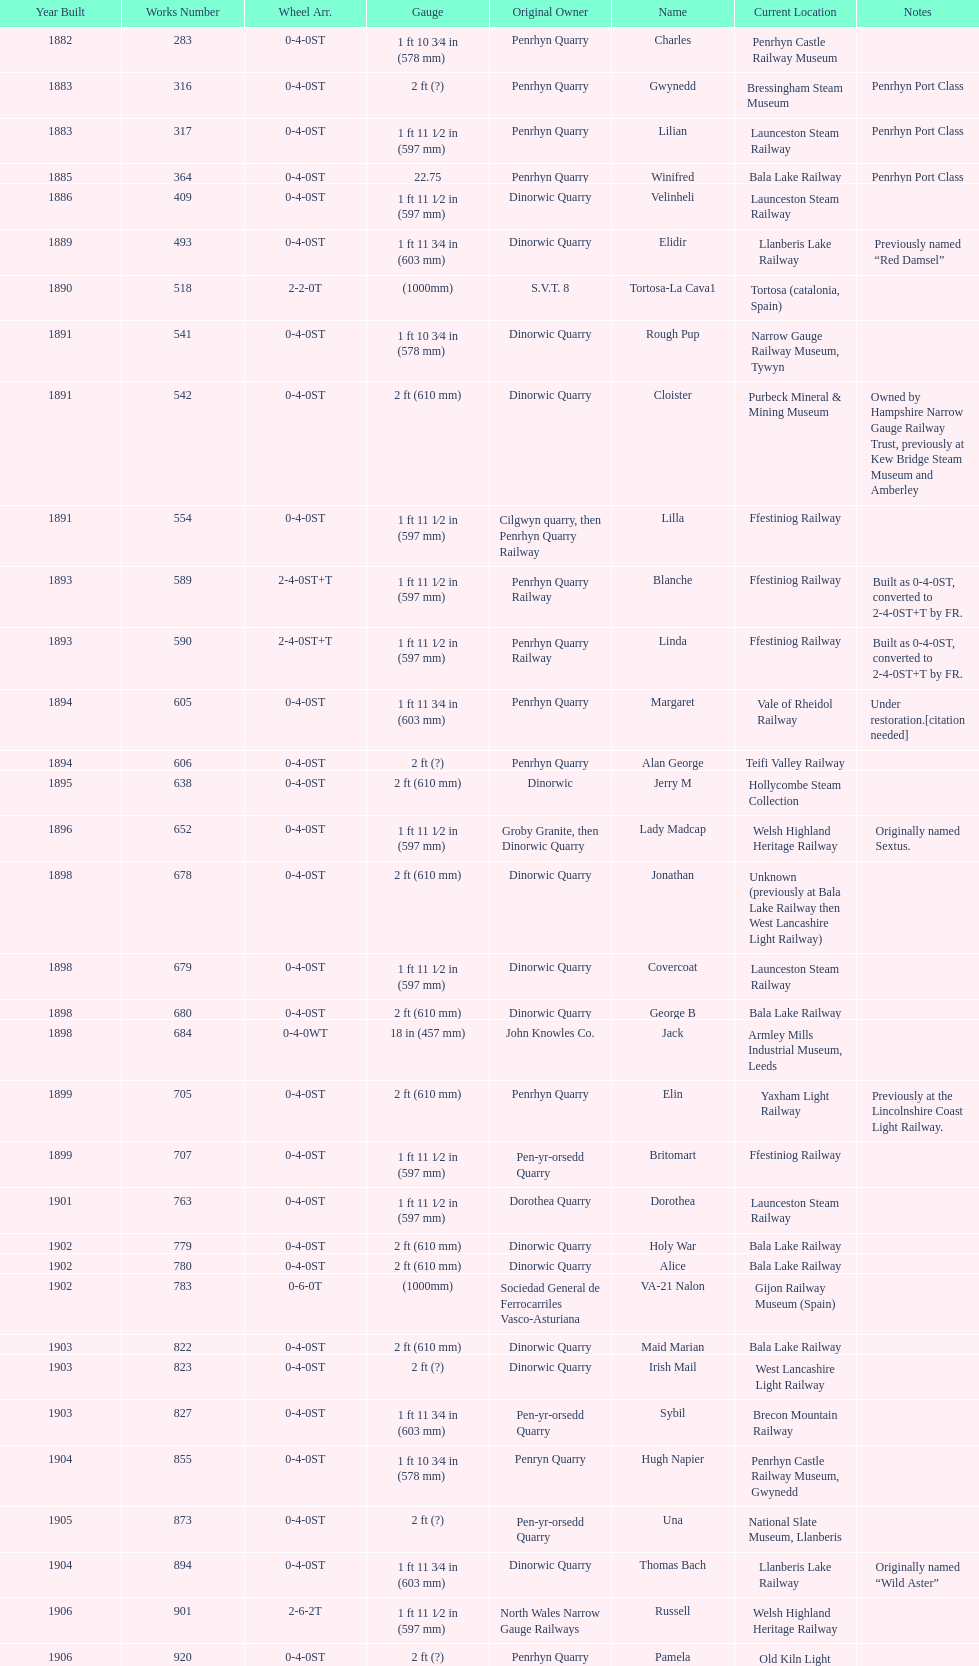What is the total number of preserved hunslet narrow gauge locomotives currently located in ffestiniog railway 554. 